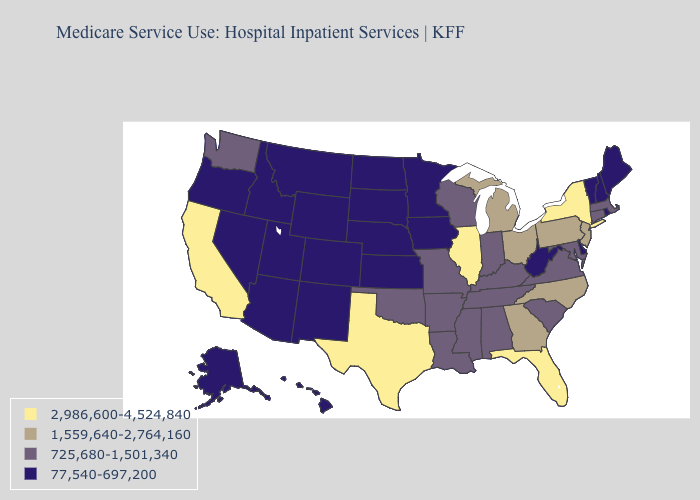Among the states that border Kentucky , does Virginia have the highest value?
Concise answer only. No. What is the value of West Virginia?
Give a very brief answer. 77,540-697,200. Among the states that border Indiana , does Ohio have the lowest value?
Short answer required. No. Name the states that have a value in the range 2,986,600-4,524,840?
Be succinct. California, Florida, Illinois, New York, Texas. Which states hav the highest value in the South?
Answer briefly. Florida, Texas. Does Vermont have the lowest value in the USA?
Short answer required. Yes. Does Virginia have the highest value in the USA?
Concise answer only. No. Name the states that have a value in the range 725,680-1,501,340?
Be succinct. Alabama, Arkansas, Connecticut, Indiana, Kentucky, Louisiana, Maryland, Massachusetts, Mississippi, Missouri, Oklahoma, South Carolina, Tennessee, Virginia, Washington, Wisconsin. What is the value of Oregon?
Answer briefly. 77,540-697,200. What is the highest value in the USA?
Keep it brief. 2,986,600-4,524,840. What is the value of Wisconsin?
Write a very short answer. 725,680-1,501,340. What is the value of West Virginia?
Quick response, please. 77,540-697,200. Among the states that border Nebraska , does Wyoming have the lowest value?
Write a very short answer. Yes. What is the lowest value in states that border Virginia?
Short answer required. 77,540-697,200. Does Pennsylvania have the highest value in the USA?
Be succinct. No. 